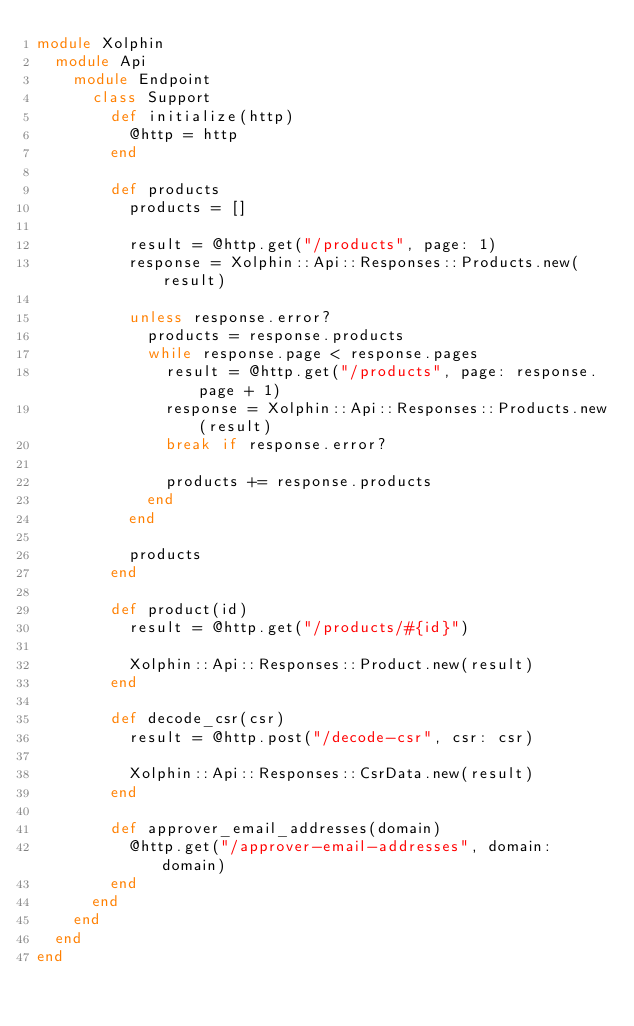<code> <loc_0><loc_0><loc_500><loc_500><_Ruby_>module Xolphin
  module Api
    module Endpoint
      class Support
        def initialize(http)
          @http = http
        end

        def products
          products = []

          result = @http.get("/products", page: 1)
          response = Xolphin::Api::Responses::Products.new(result)

          unless response.error?
            products = response.products
            while response.page < response.pages
              result = @http.get("/products", page: response.page + 1)
              response = Xolphin::Api::Responses::Products.new(result)
              break if response.error?

              products += response.products
            end
          end

          products
        end

        def product(id)
          result = @http.get("/products/#{id}")

          Xolphin::Api::Responses::Product.new(result)
        end

        def decode_csr(csr)
          result = @http.post("/decode-csr", csr: csr)

          Xolphin::Api::Responses::CsrData.new(result)
        end

        def approver_email_addresses(domain)
          @http.get("/approver-email-addresses", domain: domain)
        end
      end
    end
  end
end
</code> 